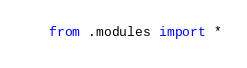<code> <loc_0><loc_0><loc_500><loc_500><_Python_>from .modules import *
</code> 